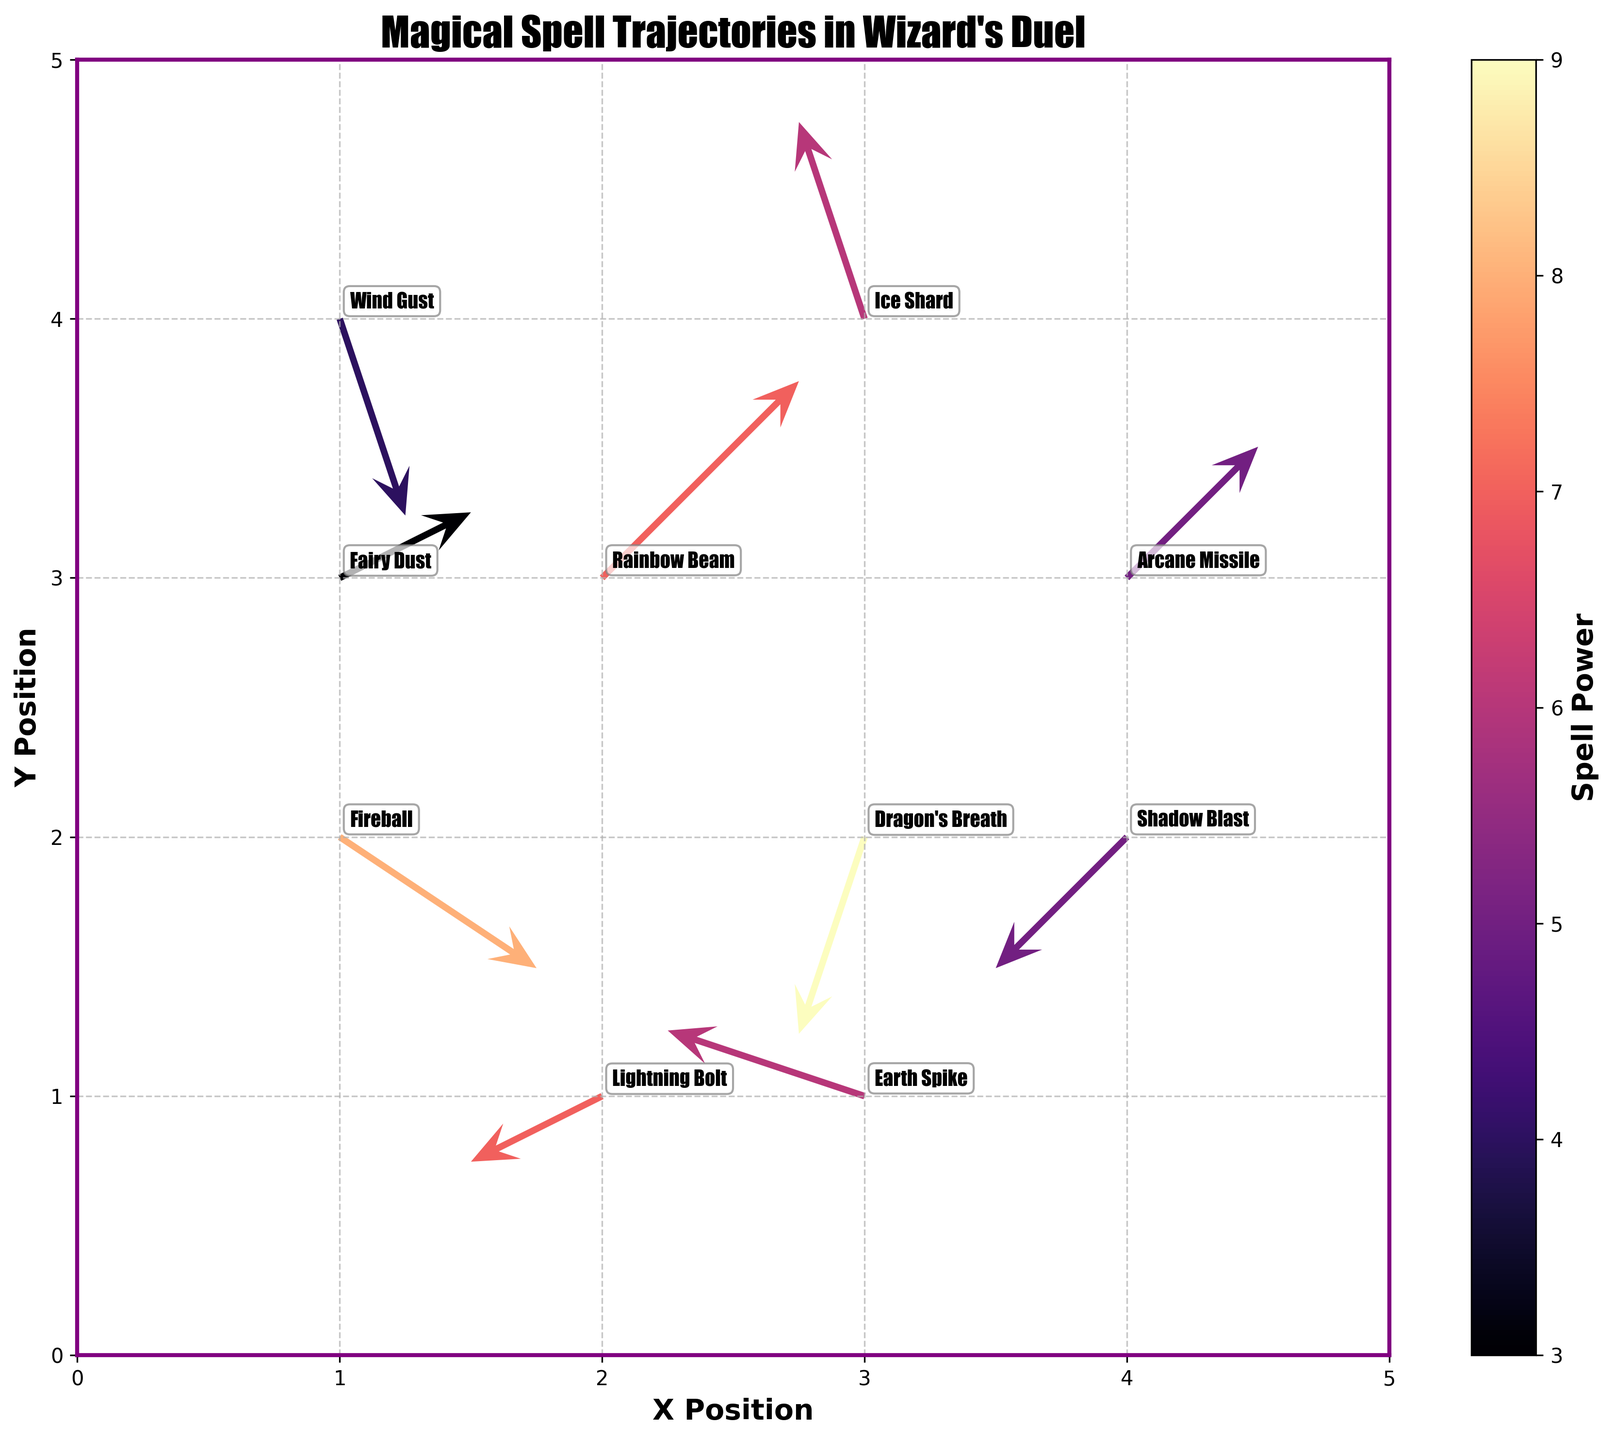What is the title of the plot? The title of the plot is the text prominently displayed at the top of the figure, usually indicating what the plot is about. In this case, it reads "Magical Spell Trajectories in Wizard's Duel".
Answer: Magical Spell Trajectories in Wizard's Duel How many spells are shown in the plot? Each spell is represented by a quiver (arrow) with its name annotated near the quiver's base. Counting these annotations gives the total number of spells.
Answer: 10 Which spell has the highest power? The spell's power is indicated by the color of the quiver as marked by the color bar labeled "Spell Power". The annotation closest to the color denoting the highest power on this scale identifies the most powerful spell.
Answer: Dragon's Breath What are the x and y coordinates of the spell "Ice Shard"? Find the annotation labeled "Ice Shard" on the plot, then read its x and y coordinates from the axes.
Answer: (3, 4) What is the direction of the "Arcane Missile" spell? Look for the quiver with the label "Arcane Missile". The direction of the quiver's arrow indicates the direction of the spell. The arrow points northeast.
Answer: Northeast Which spell travels the furthest distance from its origin point? Calculate the distance each spell travels using the Pythagorean theorem \( \sqrt{u^2 + v^2} \). The spell with the highest value of this calculation has traveled the furthest.
Answer: Rainbow Beam How does the direction of "Lightning Bolt" compare to "Shadow Blast"? Locate the quivers labeled "Lightning Bolt" and "Shadow Blast". Compare their directions by examining the directions of the quiver arrows. "Lightning Bolt" goes southwest, while "Shadow Blast" goes southwest as well, but with a different trajectory.
Answer: Different angles in the same general direction Which spells have a negative x or y component in their trajectory? A quiver's x and y components are viewed based on the arrow direction from the origin point. Identify spells where either component is negative.
Answer: Fireball, Earth Spike, Dragon's Breath, Ice Shard, Lightning Bolt, Shadow Blast What is the color of the quiver representing "Wind Gust", and what does this color indicate about its power? Find "Wind Gust" on the plot, then determine its quiver's color. Compare this color to the color bar to interpret the power level it represents.
Answer: Orange, indicating power level 4 What is the average power of all the spells shown in the plot? Sum the power levels of all spells (8 + 6 + 7 + 5 + 4 + 6 + 7 + 5 + 3 + 9) and divide by the number of spells (10) to find the average.
Answer: Average power is 6 